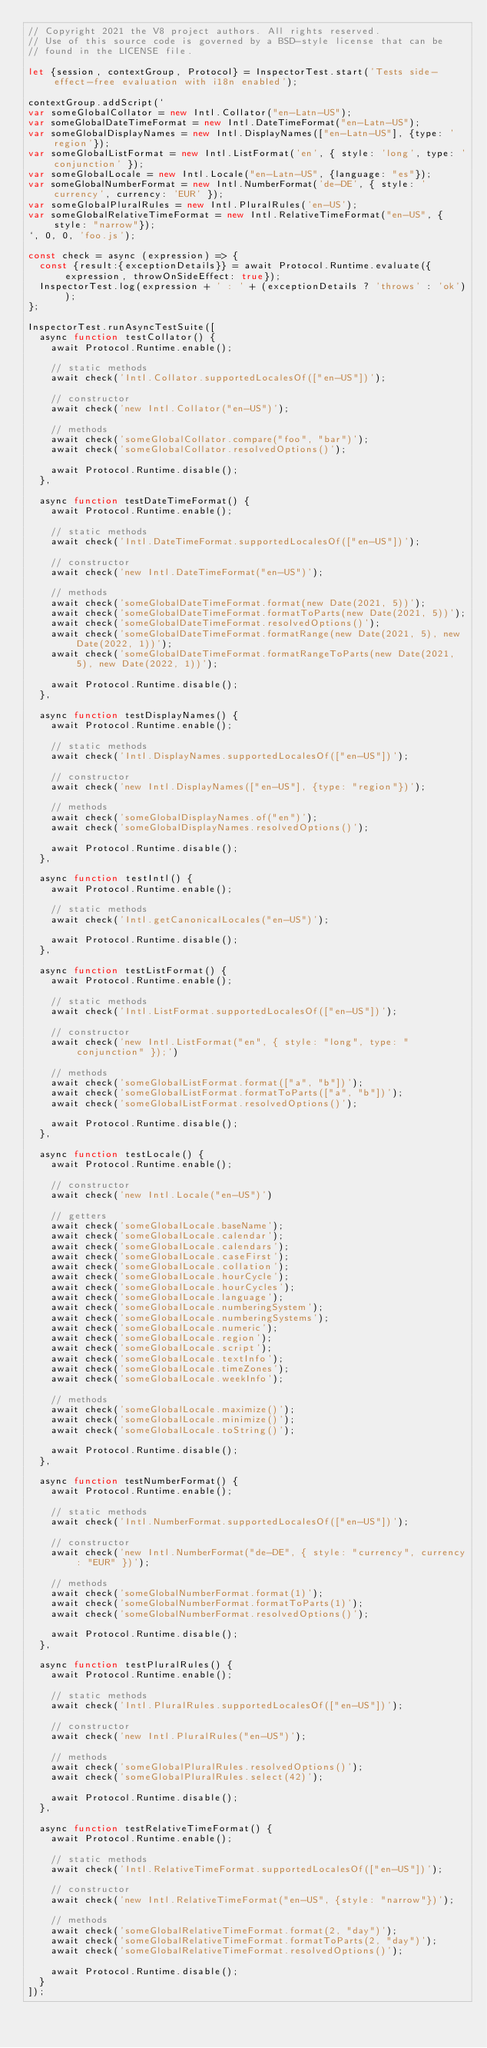Convert code to text. <code><loc_0><loc_0><loc_500><loc_500><_JavaScript_>// Copyright 2021 the V8 project authors. All rights reserved.
// Use of this source code is governed by a BSD-style license that can be
// found in the LICENSE file.

let {session, contextGroup, Protocol} = InspectorTest.start('Tests side-effect-free evaluation with i18n enabled');

contextGroup.addScript(`
var someGlobalCollator = new Intl.Collator("en-Latn-US");
var someGlobalDateTimeFormat = new Intl.DateTimeFormat("en-Latn-US");
var someGlobalDisplayNames = new Intl.DisplayNames(["en-Latn-US"], {type: 'region'});
var someGlobalListFormat = new Intl.ListFormat('en', { style: 'long', type: 'conjunction' });
var someGlobalLocale = new Intl.Locale("en-Latn-US", {language: "es"});
var someGlobalNumberFormat = new Intl.NumberFormat('de-DE', { style: 'currency', currency: 'EUR' });
var someGlobalPluralRules = new Intl.PluralRules('en-US');
var someGlobalRelativeTimeFormat = new Intl.RelativeTimeFormat("en-US", {style: "narrow"});
`, 0, 0, 'foo.js');

const check = async (expression) => {
  const {result:{exceptionDetails}} = await Protocol.Runtime.evaluate({expression, throwOnSideEffect: true});
  InspectorTest.log(expression + ' : ' + (exceptionDetails ? 'throws' : 'ok'));
};

InspectorTest.runAsyncTestSuite([
  async function testCollator() {
    await Protocol.Runtime.enable();

    // static methods
    await check('Intl.Collator.supportedLocalesOf(["en-US"])');

    // constructor
    await check('new Intl.Collator("en-US")');

    // methods
    await check('someGlobalCollator.compare("foo", "bar")');
    await check('someGlobalCollator.resolvedOptions()');

    await Protocol.Runtime.disable();
  },

  async function testDateTimeFormat() {
    await Protocol.Runtime.enable();

    // static methods
    await check('Intl.DateTimeFormat.supportedLocalesOf(["en-US"])');

    // constructor
    await check('new Intl.DateTimeFormat("en-US")');

    // methods
    await check('someGlobalDateTimeFormat.format(new Date(2021, 5))');
    await check('someGlobalDateTimeFormat.formatToParts(new Date(2021, 5))');
    await check('someGlobalDateTimeFormat.resolvedOptions()');
    await check('someGlobalDateTimeFormat.formatRange(new Date(2021, 5), new Date(2022, 1))');
    await check('someGlobalDateTimeFormat.formatRangeToParts(new Date(2021, 5), new Date(2022, 1))');

    await Protocol.Runtime.disable();
  },

  async function testDisplayNames() {
    await Protocol.Runtime.enable();

    // static methods
    await check('Intl.DisplayNames.supportedLocalesOf(["en-US"])');

    // constructor
    await check('new Intl.DisplayNames(["en-US"], {type: "region"})');

    // methods
    await check('someGlobalDisplayNames.of("en")');
    await check('someGlobalDisplayNames.resolvedOptions()');

    await Protocol.Runtime.disable();
  },

  async function testIntl() {
    await Protocol.Runtime.enable();

    // static methods
    await check('Intl.getCanonicalLocales("en-US")');

    await Protocol.Runtime.disable();
  },

  async function testListFormat() {
    await Protocol.Runtime.enable();

    // static methods
    await check('Intl.ListFormat.supportedLocalesOf(["en-US"])');

    // constructor
    await check('new Intl.ListFormat("en", { style: "long", type: "conjunction" });')

    // methods
    await check('someGlobalListFormat.format(["a", "b"])');
    await check('someGlobalListFormat.formatToParts(["a", "b"])');
    await check('someGlobalListFormat.resolvedOptions()');

    await Protocol.Runtime.disable();
  },

  async function testLocale() {
    await Protocol.Runtime.enable();

    // constructor
    await check('new Intl.Locale("en-US")')

    // getters
    await check('someGlobalLocale.baseName');
    await check('someGlobalLocale.calendar');
    await check('someGlobalLocale.calendars');
    await check('someGlobalLocale.caseFirst');
    await check('someGlobalLocale.collation');
    await check('someGlobalLocale.hourCycle');
    await check('someGlobalLocale.hourCycles');
    await check('someGlobalLocale.language');
    await check('someGlobalLocale.numberingSystem');
    await check('someGlobalLocale.numberingSystems');
    await check('someGlobalLocale.numeric');
    await check('someGlobalLocale.region');
    await check('someGlobalLocale.script');
    await check('someGlobalLocale.textInfo');
    await check('someGlobalLocale.timeZones');
    await check('someGlobalLocale.weekInfo');

    // methods
    await check('someGlobalLocale.maximize()');
    await check('someGlobalLocale.minimize()');
    await check('someGlobalLocale.toString()');

    await Protocol.Runtime.disable();
  },

  async function testNumberFormat() {
    await Protocol.Runtime.enable();

    // static methods
    await check('Intl.NumberFormat.supportedLocalesOf(["en-US"])');

    // constructor
    await check('new Intl.NumberFormat("de-DE", { style: "currency", currency: "EUR" })');

    // methods
    await check('someGlobalNumberFormat.format(1)');
    await check('someGlobalNumberFormat.formatToParts(1)');
    await check('someGlobalNumberFormat.resolvedOptions()');

    await Protocol.Runtime.disable();
  },

  async function testPluralRules() {
    await Protocol.Runtime.enable();

    // static methods
    await check('Intl.PluralRules.supportedLocalesOf(["en-US"])');

    // constructor
    await check('new Intl.PluralRules("en-US")');

    // methods
    await check('someGlobalPluralRules.resolvedOptions()');
    await check('someGlobalPluralRules.select(42)');

    await Protocol.Runtime.disable();
  },

  async function testRelativeTimeFormat() {
    await Protocol.Runtime.enable();

    // static methods
    await check('Intl.RelativeTimeFormat.supportedLocalesOf(["en-US"])');

    // constructor
    await check('new Intl.RelativeTimeFormat("en-US", {style: "narrow"})');

    // methods
    await check('someGlobalRelativeTimeFormat.format(2, "day")');
    await check('someGlobalRelativeTimeFormat.formatToParts(2, "day")');
    await check('someGlobalRelativeTimeFormat.resolvedOptions()');

    await Protocol.Runtime.disable();
  }
]);
</code> 